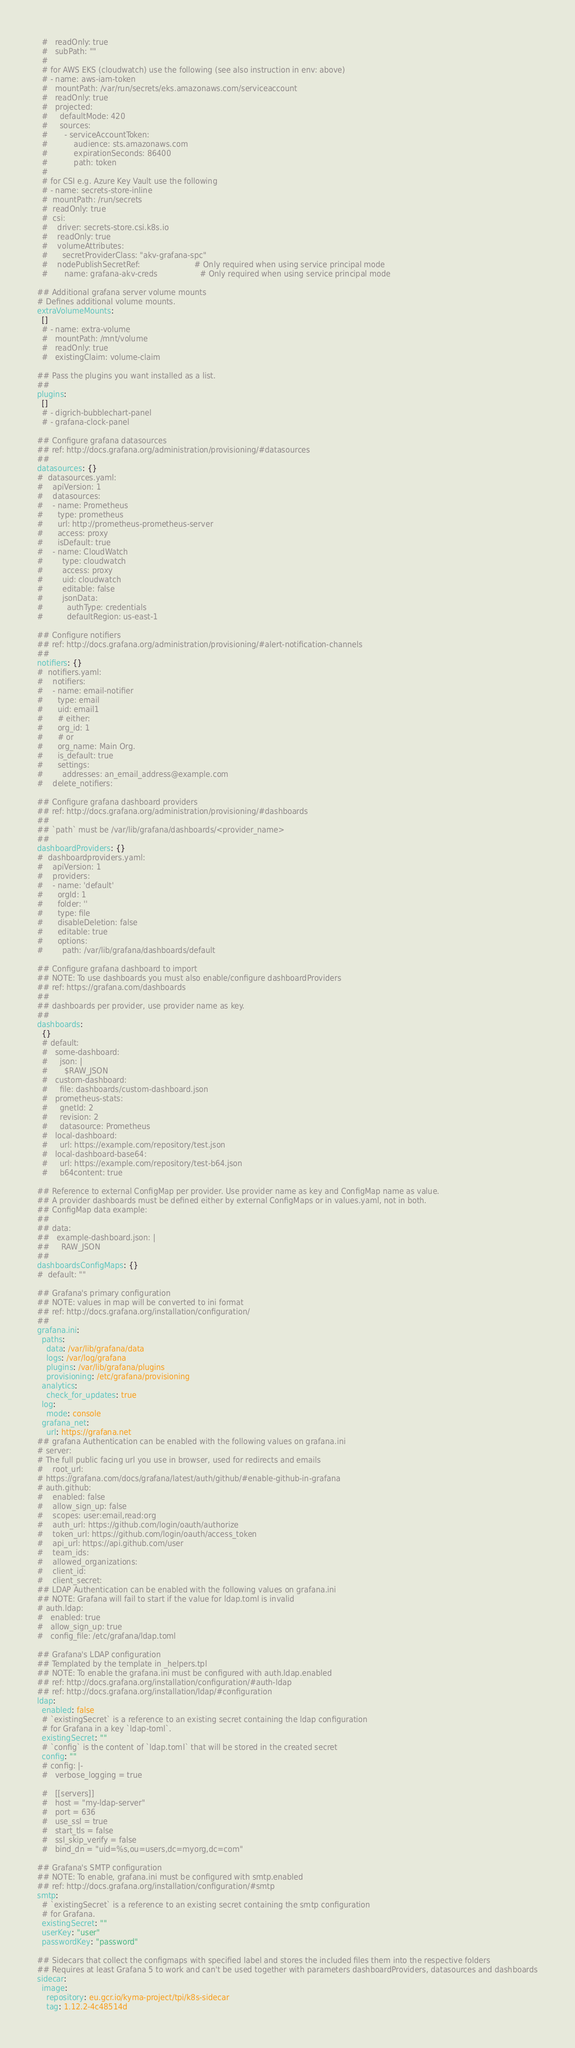Convert code to text. <code><loc_0><loc_0><loc_500><loc_500><_YAML_>  #   readOnly: true
  #   subPath: ""
  #
  # for AWS EKS (cloudwatch) use the following (see also instruction in env: above)
  # - name: aws-iam-token
  #   mountPath: /var/run/secrets/eks.amazonaws.com/serviceaccount
  #   readOnly: true
  #   projected:
  #     defaultMode: 420
  #     sources:
  #       - serviceAccountToken:
  #           audience: sts.amazonaws.com
  #           expirationSeconds: 86400
  #           path: token
  #
  # for CSI e.g. Azure Key Vault use the following
  # - name: secrets-store-inline
  #  mountPath: /run/secrets
  #  readOnly: true
  #  csi:
  #    driver: secrets-store.csi.k8s.io
  #    readOnly: true
  #    volumeAttributes:
  #      secretProviderClass: "akv-grafana-spc"
  #    nodePublishSecretRef:                       # Only required when using service principal mode
  #       name: grafana-akv-creds                  # Only required when using service principal mode

## Additional grafana server volume mounts
# Defines additional volume mounts.
extraVolumeMounts:
  []
  # - name: extra-volume
  #   mountPath: /mnt/volume
  #   readOnly: true
  #   existingClaim: volume-claim

## Pass the plugins you want installed as a list.
##
plugins:
  []
  # - digrich-bubblechart-panel
  # - grafana-clock-panel

## Configure grafana datasources
## ref: http://docs.grafana.org/administration/provisioning/#datasources
##
datasources: {}
#  datasources.yaml:
#    apiVersion: 1
#    datasources:
#    - name: Prometheus
#      type: prometheus
#      url: http://prometheus-prometheus-server
#      access: proxy
#      isDefault: true
#    - name: CloudWatch
#        type: cloudwatch
#        access: proxy
#        uid: cloudwatch
#        editable: false
#        jsonData:
#          authType: credentials
#          defaultRegion: us-east-1

## Configure notifiers
## ref: http://docs.grafana.org/administration/provisioning/#alert-notification-channels
##
notifiers: {}
#  notifiers.yaml:
#    notifiers:
#    - name: email-notifier
#      type: email
#      uid: email1
#      # either:
#      org_id: 1
#      # or
#      org_name: Main Org.
#      is_default: true
#      settings:
#        addresses: an_email_address@example.com
#    delete_notifiers:

## Configure grafana dashboard providers
## ref: http://docs.grafana.org/administration/provisioning/#dashboards
##
## `path` must be /var/lib/grafana/dashboards/<provider_name>
##
dashboardProviders: {}
#  dashboardproviders.yaml:
#    apiVersion: 1
#    providers:
#    - name: 'default'
#      orgId: 1
#      folder: ''
#      type: file
#      disableDeletion: false
#      editable: true
#      options:
#        path: /var/lib/grafana/dashboards/default

## Configure grafana dashboard to import
## NOTE: To use dashboards you must also enable/configure dashboardProviders
## ref: https://grafana.com/dashboards
##
## dashboards per provider, use provider name as key.
##
dashboards:
  {}
  # default:
  #   some-dashboard:
  #     json: |
  #       $RAW_JSON
  #   custom-dashboard:
  #     file: dashboards/custom-dashboard.json
  #   prometheus-stats:
  #     gnetId: 2
  #     revision: 2
  #     datasource: Prometheus
  #   local-dashboard:
  #     url: https://example.com/repository/test.json
  #   local-dashboard-base64:
  #     url: https://example.com/repository/test-b64.json
  #     b64content: true

## Reference to external ConfigMap per provider. Use provider name as key and ConfigMap name as value.
## A provider dashboards must be defined either by external ConfigMaps or in values.yaml, not in both.
## ConfigMap data example:
##
## data:
##   example-dashboard.json: |
##     RAW_JSON
##
dashboardsConfigMaps: {}
#  default: ""

## Grafana's primary configuration
## NOTE: values in map will be converted to ini format
## ref: http://docs.grafana.org/installation/configuration/
##
grafana.ini:
  paths:
    data: /var/lib/grafana/data
    logs: /var/log/grafana
    plugins: /var/lib/grafana/plugins
    provisioning: /etc/grafana/provisioning
  analytics:
    check_for_updates: true
  log:
    mode: console
  grafana_net:
    url: https://grafana.net
## grafana Authentication can be enabled with the following values on grafana.ini
# server:
# The full public facing url you use in browser, used for redirects and emails
#    root_url:
# https://grafana.com/docs/grafana/latest/auth/github/#enable-github-in-grafana
# auth.github:
#    enabled: false
#    allow_sign_up: false
#    scopes: user:email,read:org
#    auth_url: https://github.com/login/oauth/authorize
#    token_url: https://github.com/login/oauth/access_token
#    api_url: https://api.github.com/user
#    team_ids:
#    allowed_organizations:
#    client_id:
#    client_secret:
## LDAP Authentication can be enabled with the following values on grafana.ini
## NOTE: Grafana will fail to start if the value for ldap.toml is invalid
# auth.ldap:
#   enabled: true
#   allow_sign_up: true
#   config_file: /etc/grafana/ldap.toml

## Grafana's LDAP configuration
## Templated by the template in _helpers.tpl
## NOTE: To enable the grafana.ini must be configured with auth.ldap.enabled
## ref: http://docs.grafana.org/installation/configuration/#auth-ldap
## ref: http://docs.grafana.org/installation/ldap/#configuration
ldap:
  enabled: false
  # `existingSecret` is a reference to an existing secret containing the ldap configuration
  # for Grafana in a key `ldap-toml`.
  existingSecret: ""
  # `config` is the content of `ldap.toml` that will be stored in the created secret
  config: ""
  # config: |-
  #   verbose_logging = true

  #   [[servers]]
  #   host = "my-ldap-server"
  #   port = 636
  #   use_ssl = true
  #   start_tls = false
  #   ssl_skip_verify = false
  #   bind_dn = "uid=%s,ou=users,dc=myorg,dc=com"

## Grafana's SMTP configuration
## NOTE: To enable, grafana.ini must be configured with smtp.enabled
## ref: http://docs.grafana.org/installation/configuration/#smtp
smtp:
  # `existingSecret` is a reference to an existing secret containing the smtp configuration
  # for Grafana.
  existingSecret: ""
  userKey: "user"
  passwordKey: "password"

## Sidecars that collect the configmaps with specified label and stores the included files them into the respective folders
## Requires at least Grafana 5 to work and can't be used together with parameters dashboardProviders, datasources and dashboards
sidecar:
  image:
    repository: eu.gcr.io/kyma-project/tpi/k8s-sidecar
    tag: 1.12.2-4c48514d</code> 